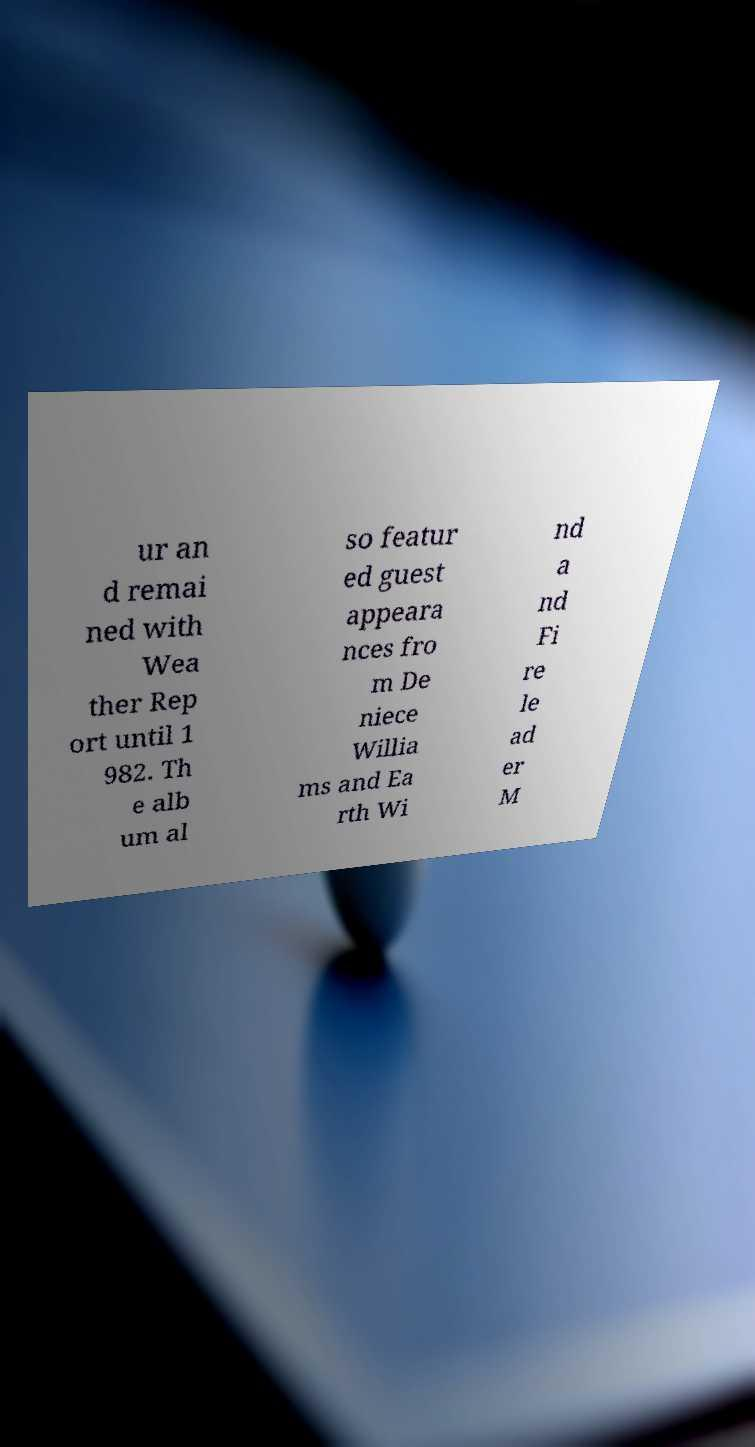Please identify and transcribe the text found in this image. ur an d remai ned with Wea ther Rep ort until 1 982. Th e alb um al so featur ed guest appeara nces fro m De niece Willia ms and Ea rth Wi nd a nd Fi re le ad er M 